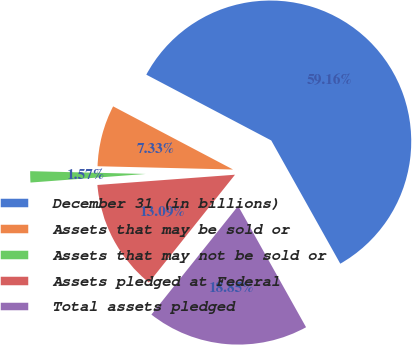Convert chart to OTSL. <chart><loc_0><loc_0><loc_500><loc_500><pie_chart><fcel>December 31 (in billions)<fcel>Assets that may be sold or<fcel>Assets that may not be sold or<fcel>Assets pledged at Federal<fcel>Total assets pledged<nl><fcel>59.16%<fcel>7.33%<fcel>1.57%<fcel>13.09%<fcel>18.85%<nl></chart> 